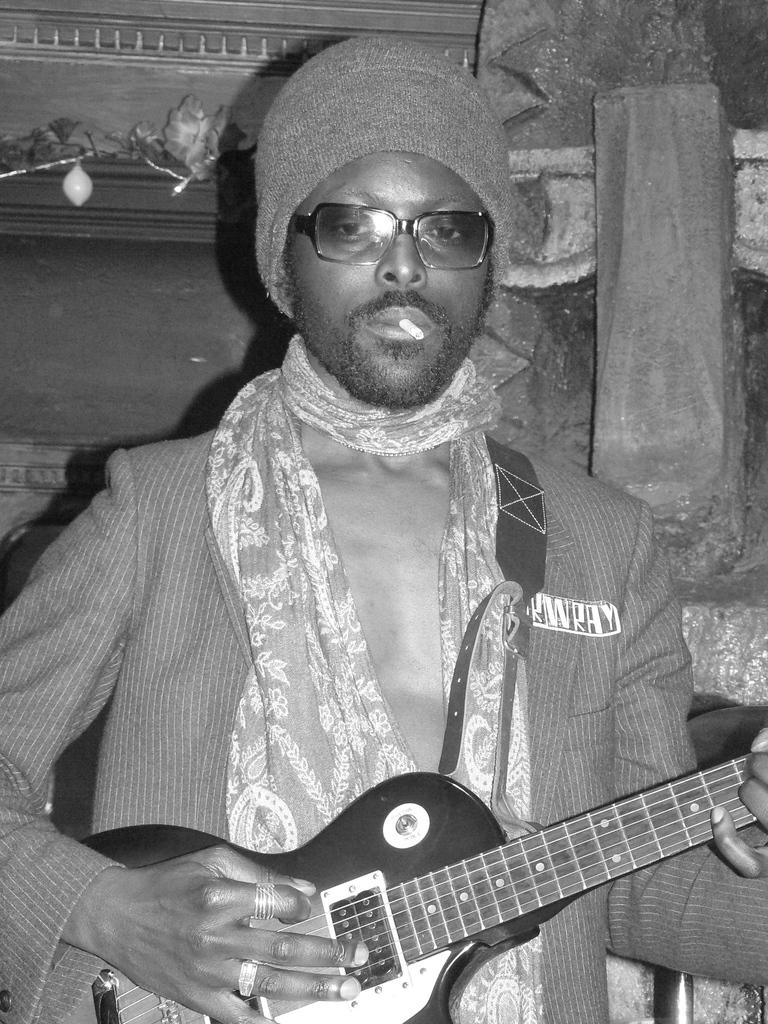What is the man in the image doing? The man is playing a guitar in the image. How is the man positioned in the image? The man is standing in the image. What can be seen in the background of the image? There are lights, a wall, and a cupboard in the background of the image. What type of glue is the man using to stick the cent to the wall in the image? There is no glue or cent present in the image; the man is playing a guitar, and there is a wall and a cupboard in the background. 